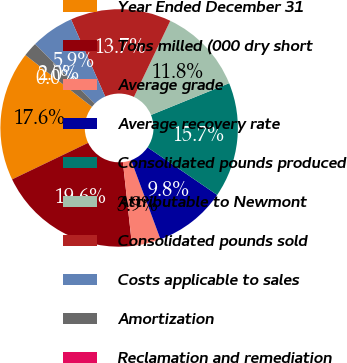Convert chart. <chart><loc_0><loc_0><loc_500><loc_500><pie_chart><fcel>Year Ended December 31<fcel>Tons milled (000 dry short<fcel>Average grade<fcel>Average recovery rate<fcel>Consolidated pounds produced<fcel>Attributable to Newmont<fcel>Consolidated pounds sold<fcel>Costs applicable to sales<fcel>Amortization<fcel>Reclamation and remediation<nl><fcel>17.65%<fcel>19.61%<fcel>3.92%<fcel>9.8%<fcel>15.69%<fcel>11.76%<fcel>13.73%<fcel>5.88%<fcel>1.96%<fcel>0.0%<nl></chart> 